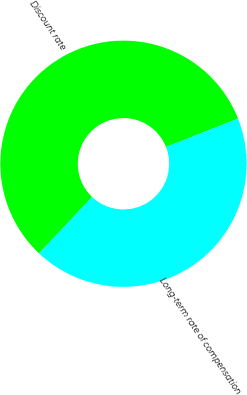Convert chart to OTSL. <chart><loc_0><loc_0><loc_500><loc_500><pie_chart><fcel>Discount rate<fcel>Long-term rate of compensation<nl><fcel>57.0%<fcel>43.0%<nl></chart> 